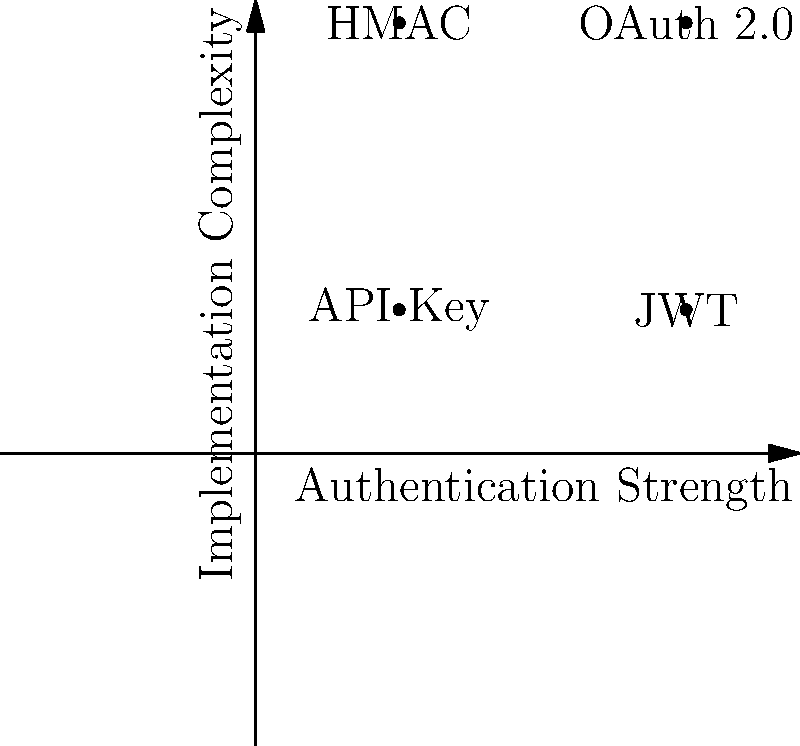In the given Cartesian plane, four common API authentication methods are mapped based on their authentication strength and implementation complexity. Which method is represented by the point (0.75, 0.25), indicating high authentication strength but relatively low implementation complexity? To answer this question, let's analyze the Cartesian plane and the authentication methods plotted:

1. The x-axis represents "Authentication Strength" increasing from left to right.
2. The y-axis represents "Implementation Complexity" increasing from bottom to top.

The four authentication methods plotted are:

a) API Key: (0.25, 0.25) - Low strength, low complexity
b) OAuth 2.0: (0.75, 0.75) - High strength, high complexity
c) JWT: (0.75, 0.25) - High strength, low complexity
d) HMAC: (0.25, 0.75) - Low strength, high complexity

The point (0.75, 0.25) is located in the bottom-right quadrant, indicating high authentication strength (0.75 on the x-axis) and relatively low implementation complexity (0.25 on the y-axis).

This point corresponds to the JWT (JSON Web Token) authentication method, which offers strong security through digitally signed tokens but is relatively simple to implement compared to more complex protocols like OAuth 2.0.
Answer: JWT 